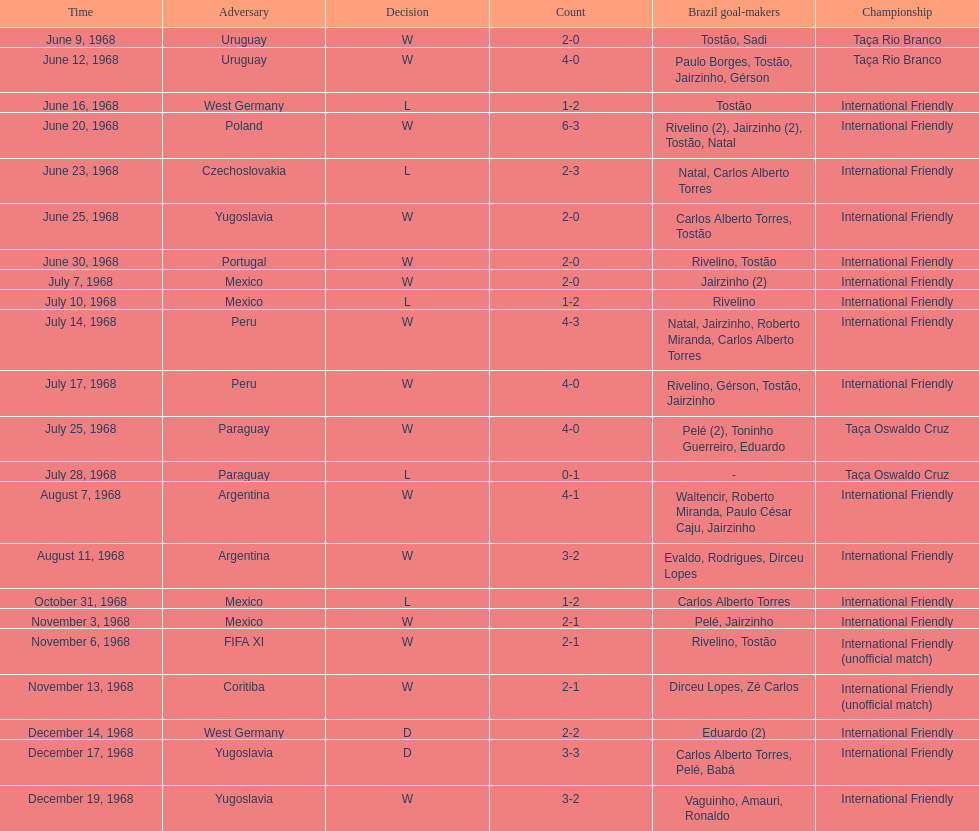How many times did brazil play against argentina in the international friendly competition? 2. 